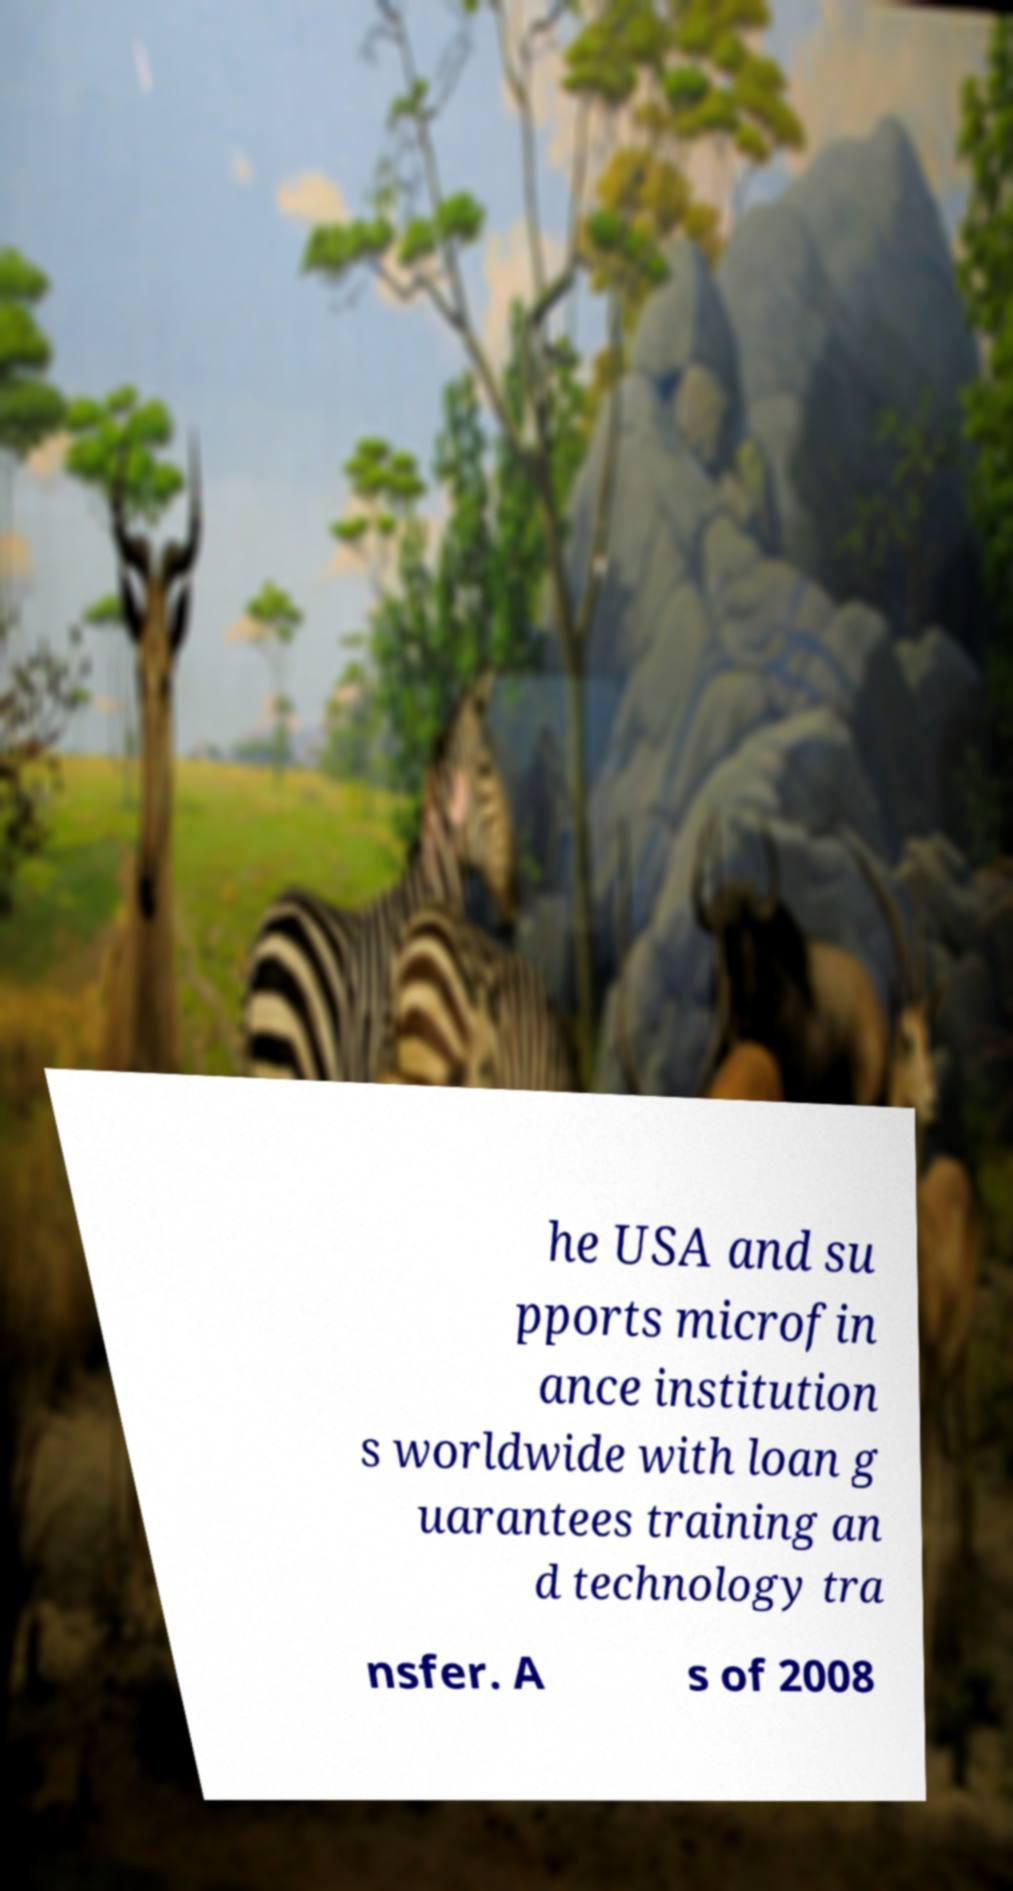What messages or text are displayed in this image? I need them in a readable, typed format. he USA and su pports microfin ance institution s worldwide with loan g uarantees training an d technology tra nsfer. A s of 2008 